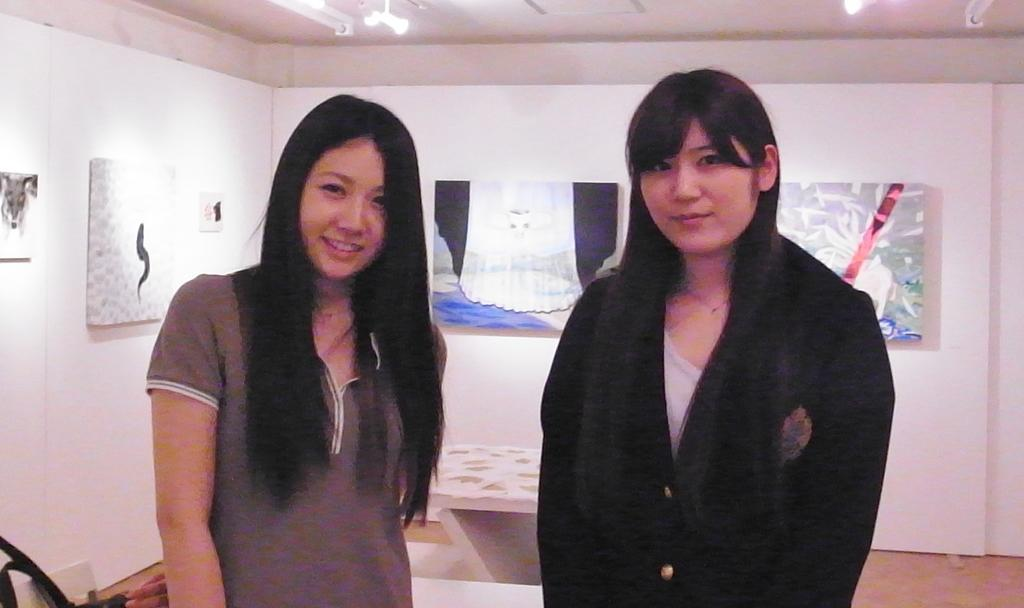How many people are present in the image? There are two people in the image. What can be observed about the clothing of the people in the image? The people are wearing different color dresses. What is located in the background of the image? There is a table and boards on the wall in the background of the image. What is visible at the top of the image? There are lights visible in the top of the image. What type of alarm can be heard going off in the image? There is no alarm present in the image, and therefore no sound can be heard. Is there a cactus visible in the image? There is no cactus present in the image. 